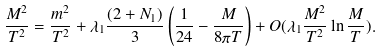Convert formula to latex. <formula><loc_0><loc_0><loc_500><loc_500>\frac { M ^ { 2 } } { T ^ { 2 } } = \frac { m ^ { 2 } } { T ^ { 2 } } + \lambda _ { 1 } \frac { ( 2 + N _ { 1 } ) } { 3 } \left ( \frac { 1 } { 2 4 } - \frac { M } { 8 \pi T } \right ) + O ( \lambda _ { 1 } \frac { M ^ { 2 } } { T ^ { 2 } } \ln \frac { M } { T } ) .</formula> 